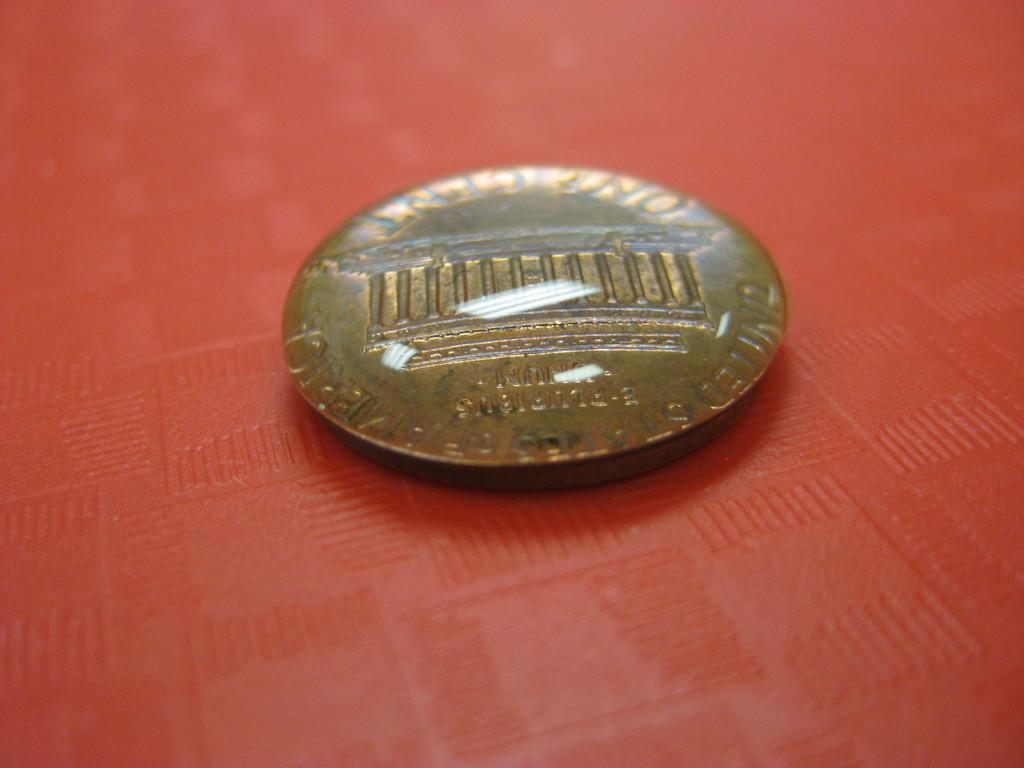<image>
Render a clear and concise summary of the photo. A one cent coin from the United States of America is laying face down. 